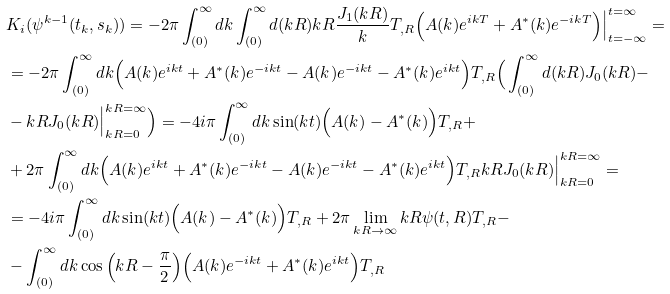<formula> <loc_0><loc_0><loc_500><loc_500>& K _ { i } ( \psi ^ { k - 1 } ( t _ { k } , s _ { k } ) ) = - 2 \pi \int _ { ( 0 ) } ^ { \infty } d k \int _ { ( 0 ) } ^ { \infty } d ( k R ) k R \frac { J _ { 1 } ( k R ) } { k } T _ { , R } \Big ( A ( k ) e ^ { i k T } + A ^ { * } ( k ) e ^ { - i k T } \Big ) \Big | ^ { t = \infty } _ { t = - \infty } = \\ & = - 2 \pi \int _ { ( 0 ) } ^ { \infty } d k \Big ( A ( k ) e ^ { i k t } + A ^ { * } ( k ) e ^ { - i k t } - A ( k ) e ^ { - i k t } - A ^ { * } ( k ) e ^ { i k t } \Big ) T _ { , R } \Big ( \int _ { ( 0 ) } ^ { \infty } d ( k R ) J _ { 0 } ( k R ) - \\ & - k R J _ { 0 } ( k R ) \Big | ^ { k R = \infty } _ { k R = 0 } \Big ) = - 4 i \pi \int _ { ( 0 ) } ^ { \infty } d k \sin ( k t ) \Big ( A ( k ) - A ^ { * } ( k ) \Big ) T _ { , R } + \\ & + 2 \pi \int _ { ( 0 ) } ^ { \infty } d k \Big ( A ( k ) e ^ { i k t } + A ^ { * } ( k ) e ^ { - i k t } - A ( k ) e ^ { - i k t } - A ^ { * } ( k ) e ^ { i k t } \Big ) T _ { , R } k R J _ { 0 } ( k R ) \Big | ^ { k R = \infty } _ { k R = 0 } = \\ & = - 4 i \pi \int _ { ( 0 ) } ^ { \infty } d k \sin ( k t ) \Big ( A ( k ) - A ^ { * } ( k ) \Big ) T _ { , R } + 2 \pi \lim _ { k R \to \infty } k R \psi ( t , R ) T _ { , R } - \\ & - \int _ { ( 0 ) } ^ { \infty } d k \cos \Big ( k R - \frac { \pi } { 2 } \Big ) \Big ( A ( k ) e ^ { - i k t } + A ^ { * } ( k ) e ^ { i k t } \Big ) T _ { , R }</formula> 